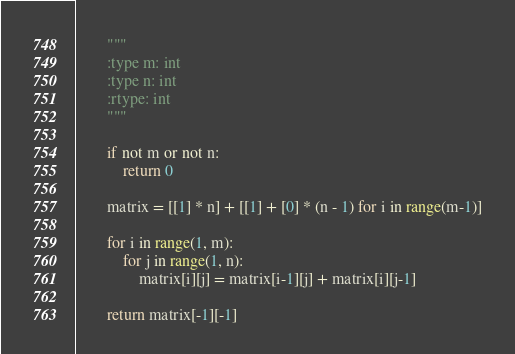<code> <loc_0><loc_0><loc_500><loc_500><_Python_>        """
        :type m: int
        :type n: int
        :rtype: int
        """
        
        if not m or not n:
            return 0
        
        matrix = [[1] * n] + [[1] + [0] * (n - 1) for i in range(m-1)]
        
        for i in range(1, m):
            for j in range(1, n):
                matrix[i][j] = matrix[i-1][j] + matrix[i][j-1]
                
        return matrix[-1][-1]</code> 